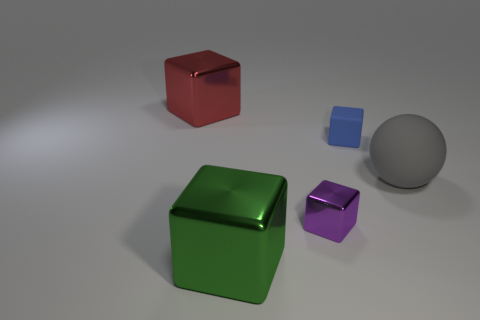Subtract all tiny blue rubber cubes. How many cubes are left? 3 Subtract all purple cubes. How many cubes are left? 3 Subtract 1 blocks. How many blocks are left? 3 Subtract all blocks. How many objects are left? 1 Add 2 red things. How many objects exist? 7 Subtract all brown balls. Subtract all yellow blocks. How many balls are left? 1 Subtract all gray rubber things. Subtract all big green objects. How many objects are left? 3 Add 5 big cubes. How many big cubes are left? 7 Add 2 large brown spheres. How many large brown spheres exist? 2 Subtract 0 brown cylinders. How many objects are left? 5 